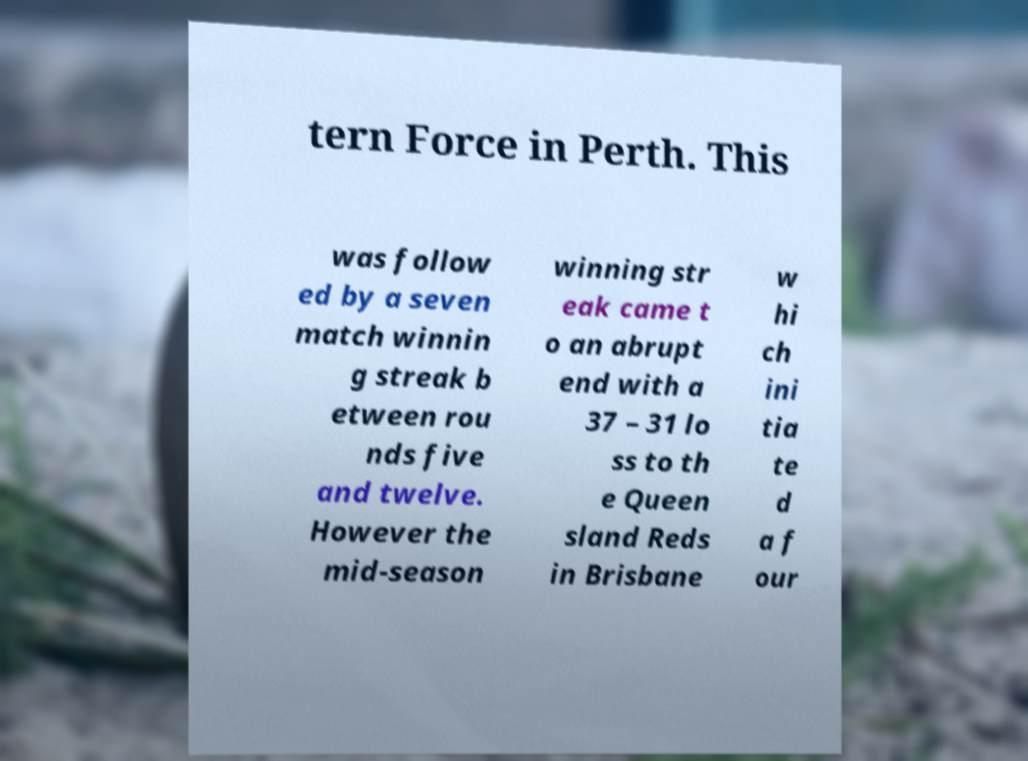For documentation purposes, I need the text within this image transcribed. Could you provide that? tern Force in Perth. This was follow ed by a seven match winnin g streak b etween rou nds five and twelve. However the mid-season winning str eak came t o an abrupt end with a 37 – 31 lo ss to th e Queen sland Reds in Brisbane w hi ch ini tia te d a f our 